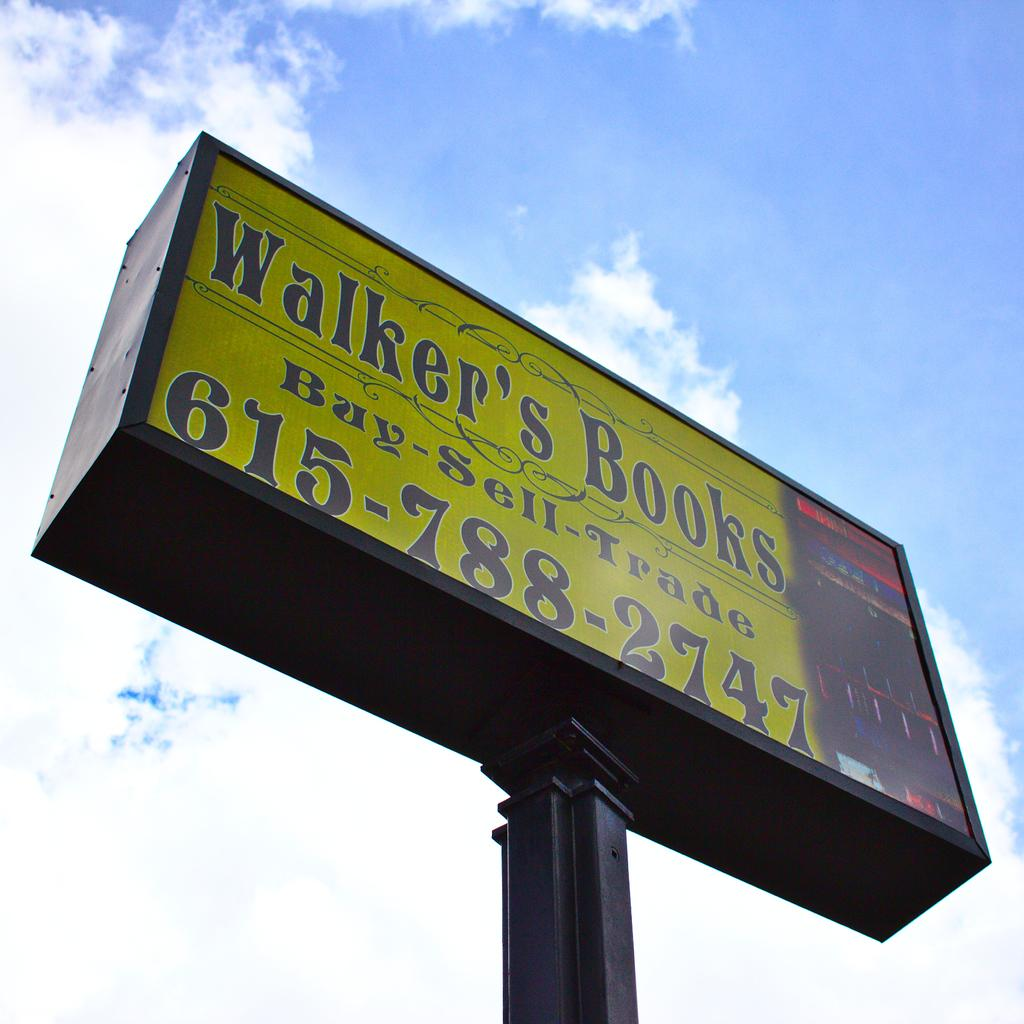<image>
Write a terse but informative summary of the picture. The sign for Walker's Books says that we can buy, sell, and trade there. 